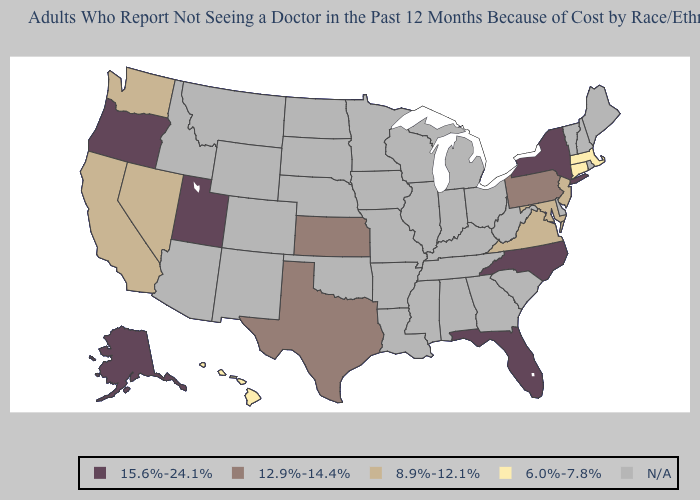Is the legend a continuous bar?
Be succinct. No. What is the value of Hawaii?
Give a very brief answer. 6.0%-7.8%. Does Maryland have the highest value in the South?
Short answer required. No. What is the lowest value in states that border Virginia?
Short answer required. 8.9%-12.1%. What is the value of North Dakota?
Be succinct. N/A. Name the states that have a value in the range 12.9%-14.4%?
Give a very brief answer. Kansas, Pennsylvania, Texas. What is the value of Tennessee?
Give a very brief answer. N/A. What is the value of New York?
Give a very brief answer. 15.6%-24.1%. Does the first symbol in the legend represent the smallest category?
Be succinct. No. Name the states that have a value in the range N/A?
Short answer required. Alabama, Arizona, Arkansas, Colorado, Delaware, Georgia, Idaho, Illinois, Indiana, Iowa, Kentucky, Louisiana, Maine, Michigan, Minnesota, Mississippi, Missouri, Montana, Nebraska, New Hampshire, New Mexico, North Dakota, Ohio, Oklahoma, Rhode Island, South Carolina, South Dakota, Tennessee, Vermont, West Virginia, Wisconsin, Wyoming. What is the lowest value in states that border Nevada?
Quick response, please. 8.9%-12.1%. What is the value of Rhode Island?
Short answer required. N/A. 